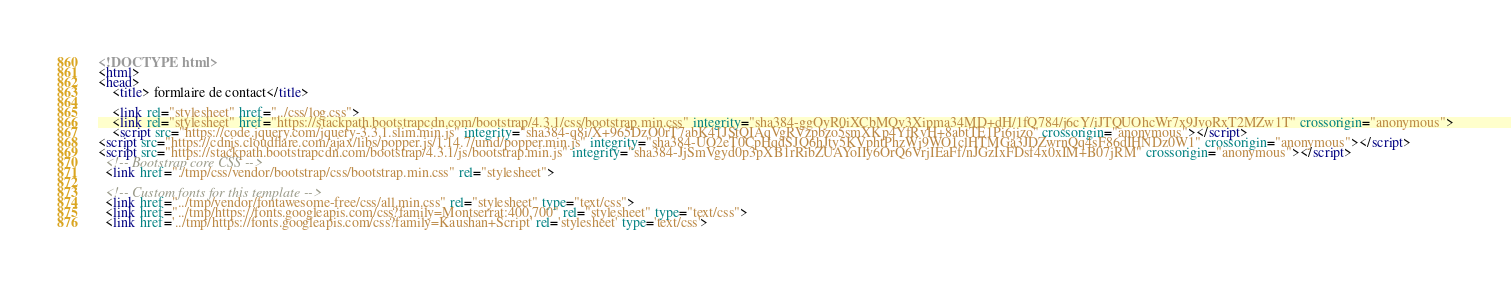Convert code to text. <code><loc_0><loc_0><loc_500><loc_500><_HTML_><!DOCTYPE html>
<html>
<head>
    <title> formlaire de contact</title>

    <link rel="stylesheet" href="../css/log.css">
    <link rel="stylesheet" href="https://stackpath.bootstrapcdn.com/bootstrap/4.3.1/css/bootstrap.min.css" integrity="sha384-ggOyR0iXCbMQv3Xipma34MD+dH/1fQ784/j6cY/iJTQUOhcWr7x9JvoRxT2MZw1T" crossorigin="anonymous">
    <script src="https://code.jquery.com/jquery-3.3.1.slim.min.js" integrity="sha384-q8i/X+965DzO0rT7abK41JStQIAqVgRVzpbzo5smXKp4YfRvH+8abtTE1Pi6jizo" crossorigin="anonymous"></script>
<script src="https://cdnjs.cloudflare.com/ajax/libs/popper.js/1.14.7/umd/popper.min.js" integrity="sha384-UO2eT0CpHqdSJQ6hJty5KVphtPhzWj9WO1clHTMGa3JDZwrnQq4sF86dIHNDz0W1" crossorigin="anonymous"></script>
<script src="https://stackpath.bootstrapcdn.com/bootstrap/4.3.1/js/bootstrap.min.js" integrity="sha384-JjSmVgyd0p3pXB1rRibZUAYoIIy6OrQ6VrjIEaFf/nJGzIxFDsf4x0xIM+B07jRM" crossorigin="anonymous"></script>
  <!-- Bootstrap core CSS -->                                                                                                                                                                                                                                   
  <link href="./tmp/css/vendor/bootstrap/css/bootstrap.min.css" rel="stylesheet">

  <!-- Custom fonts for this template -->
  <link href="../tmp/vendor/fontawesome-free/css/all.min.css" rel="stylesheet" type="text/css">
  <link href="../tmp/https://fonts.googleapis.com/css?family=Montserrat:400,700" rel="stylesheet" type="text/css">
  <link href='../tmp/https://fonts.googleapis.com/css?family=Kaushan+Script' rel='stylesheet' type='text/css'></code> 